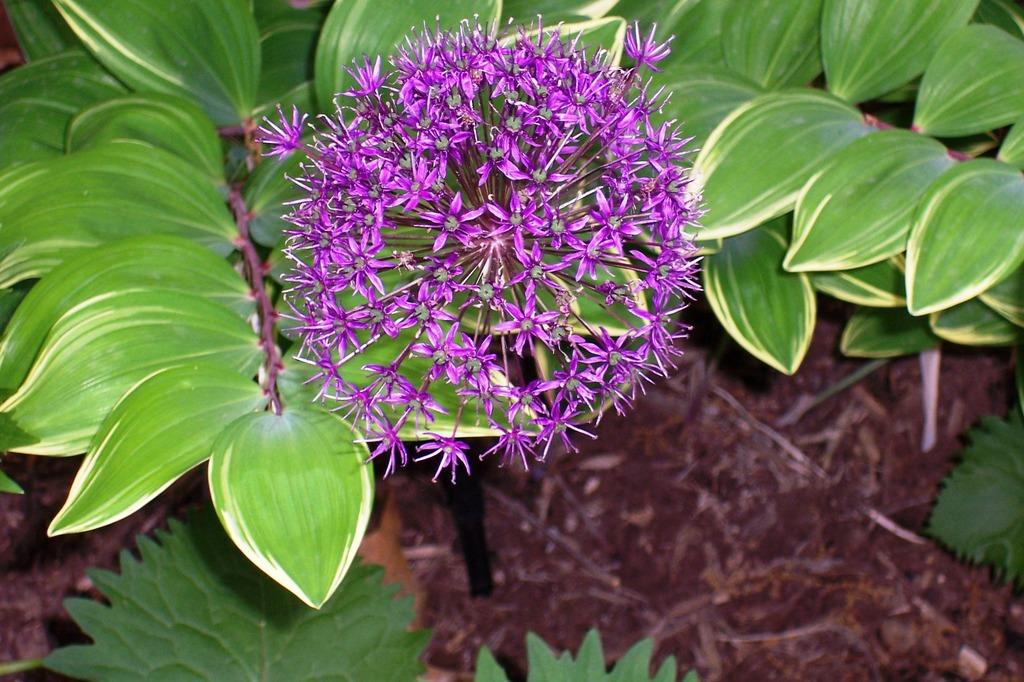What is the main subject of the image? There is a bunch of flowers in the image. Are there any other plants besides the bunch of flowers? Yes, there is a plant in the image. What can be seen in the image besides the flowers and plant? There are many leaves visible in the image. What might be the source of the leaves in the image? The soil visible on the floor in the image suggests that the leaves are from the plants. What type of sign can be seen hanging in the lunchroom in the image? There is no sign or lunchroom present in the image; it features a bunch of flowers, a plant, and leaves. 